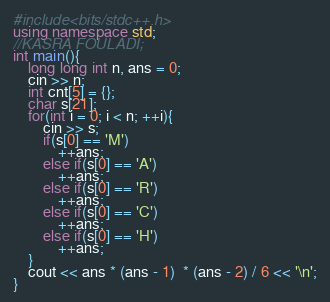Convert code to text. <code><loc_0><loc_0><loc_500><loc_500><_C++_>#include<bits/stdc++.h>
using namespace std;
//KASRA FOULADI;
int main(){
    long long int n, ans = 0;
    cin >> n;
    int cnt[5] = {};
    char s[21];
    for(int i = 0; i < n; ++i){
        cin >> s;
        if(s[0] == 'M')
            ++ans;
        else if(s[0] == 'A')
            ++ans;
        else if(s[0] == 'R')
            ++ans;
        else if(s[0] == 'C')
            ++ans;
        else if(s[0] == 'H')
            ++ans;
    }
    cout << ans * (ans - 1)  * (ans - 2) / 6 << '\n';
}</code> 